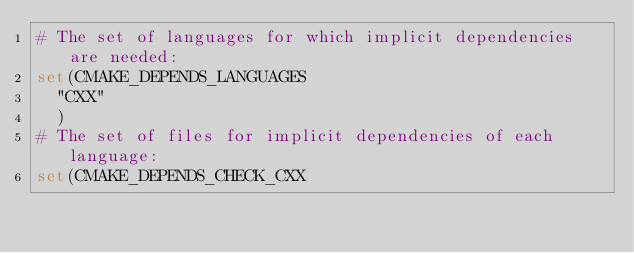<code> <loc_0><loc_0><loc_500><loc_500><_CMake_># The set of languages for which implicit dependencies are needed:
set(CMAKE_DEPENDS_LANGUAGES
  "CXX"
  )
# The set of files for implicit dependencies of each language:
set(CMAKE_DEPENDS_CHECK_CXX</code> 